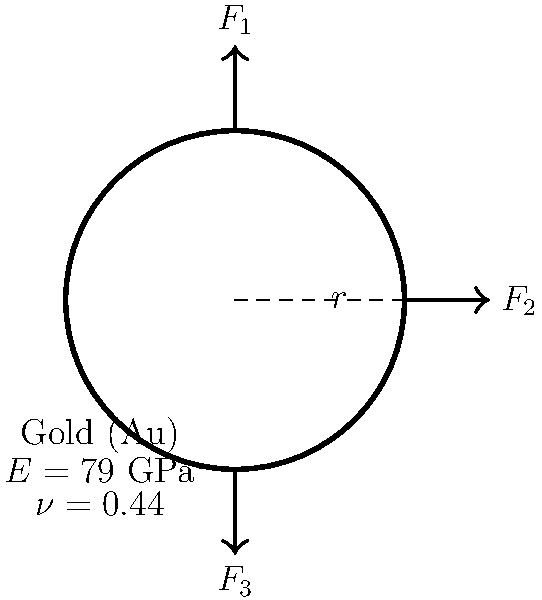A newly married couple wants to ensure their wedding rings can withstand daily wear. The bride's ring, made of gold, has an inner radius of 8 mm and a circular cross-section with a diameter of 2 mm. If three forces are applied to the ring as shown in the diagram ($F_1 = 50$ N, $F_2 = 30$ N, and $F_3 = 40$ N), calculate the maximum von Mises stress in the ring. Assume the ring behaves as a thin circular beam. To solve this problem, we'll follow these steps:

1) First, calculate the area moment of inertia for the circular cross-section:
   $I = \frac{\pi d^4}{64} = \frac{\pi (2 \text{ mm})^4}{64} = 0.7854 \text{ mm}^4$

2) Calculate the mean radius of the ring:
   $R = 8 \text{ mm} + 1 \text{ mm} = 9 \text{ mm}$

3) Determine the bending moment:
   $M = F_1R = 50 \text{ N} \cdot 9 \text{ mm} = 450 \text{ N}\cdot\text{mm}$

4) Calculate the normal stress due to bending:
   $\sigma_b = \frac{My}{I} = \frac{450 \text{ N}\cdot\text{mm} \cdot 1 \text{ mm}}{0.7854 \text{ mm}^4} = 572.96 \text{ MPa}$

5) Calculate the shear stress:
   $\tau = \frac{F_2}{A} = \frac{30 \text{ N}}{\pi (1 \text{ mm})^2} = 9.55 \text{ MPa}$

6) Calculate the von Mises stress:
   $\sigma_{VM} = \sqrt{\sigma_b^2 + 3\tau^2} = \sqrt{(572.96 \text{ MPa})^2 + 3(9.55 \text{ MPa})^2} = 573.14 \text{ MPa}$

The maximum von Mises stress occurs at the outer fibers of the ring where the bending stress is maximum.
Answer: 573.14 MPa 